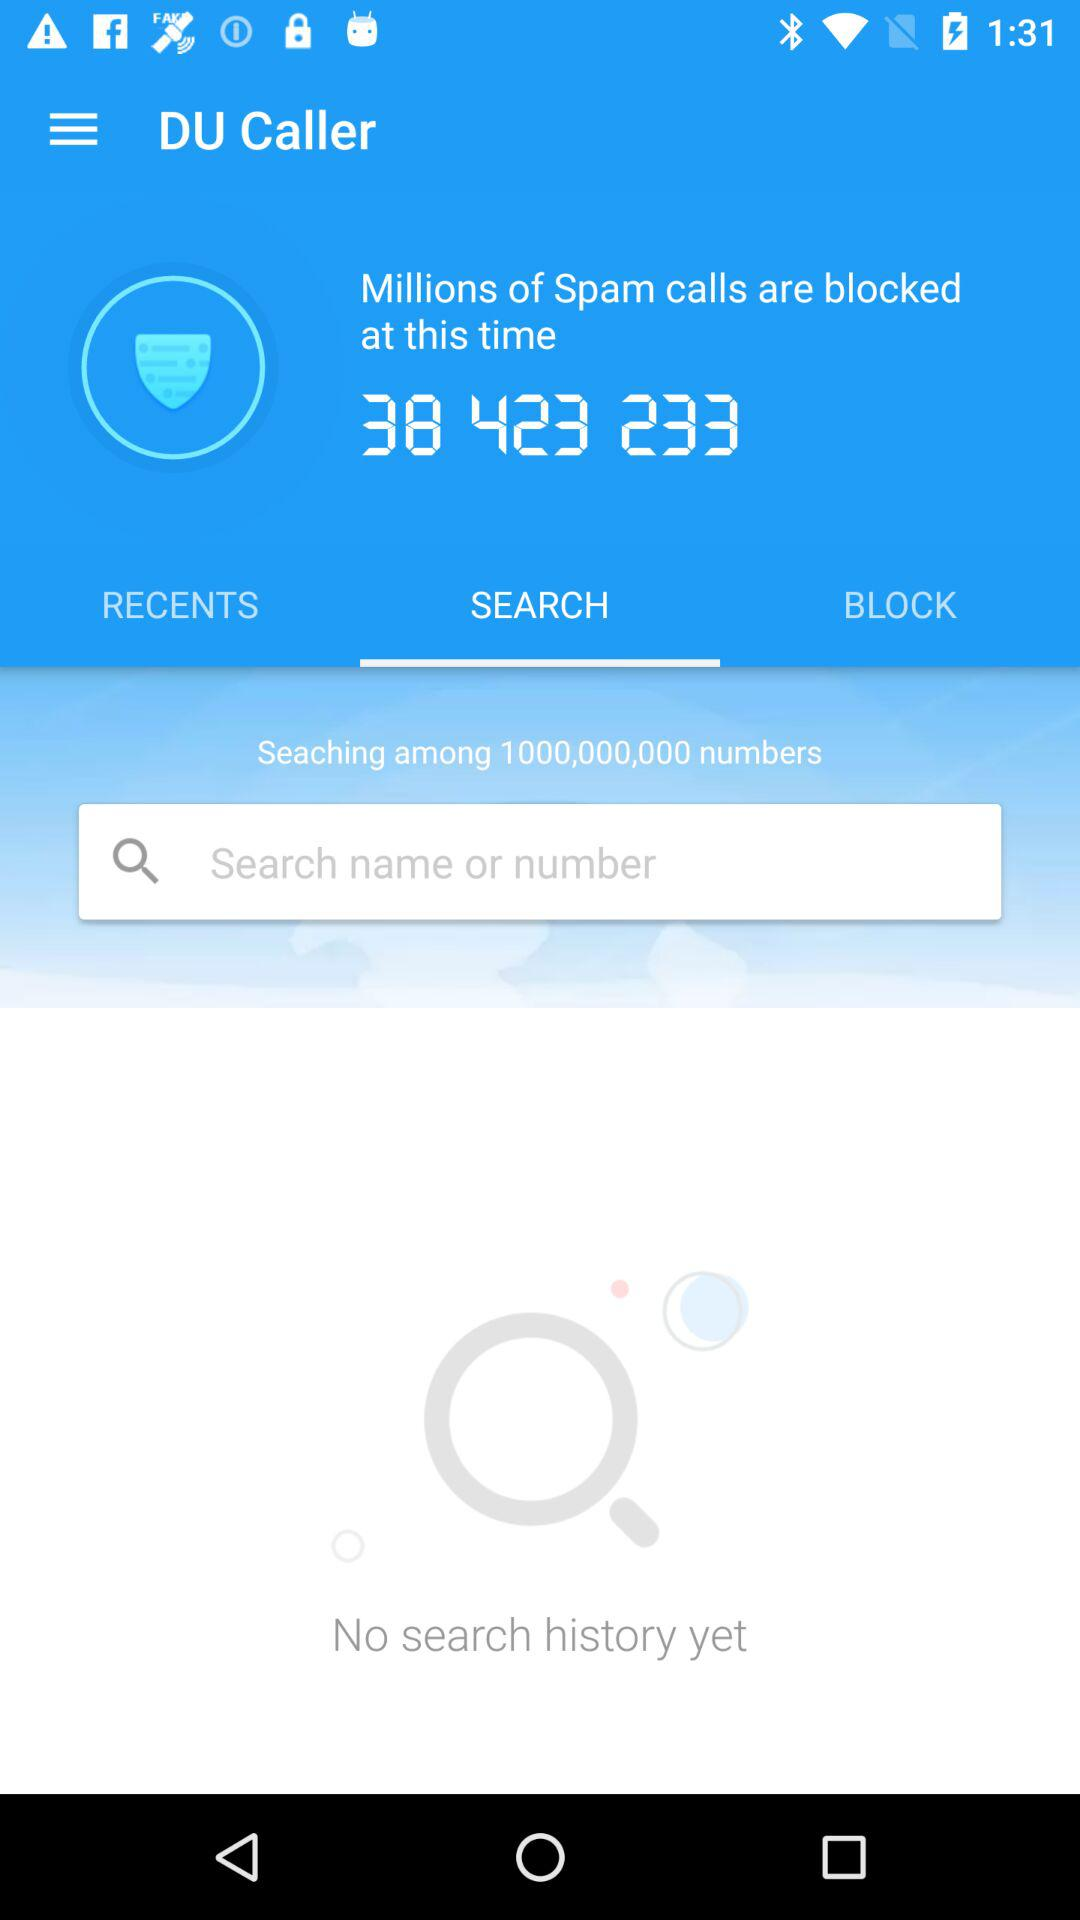Which option is selected? The selected option is "SEARCH". 